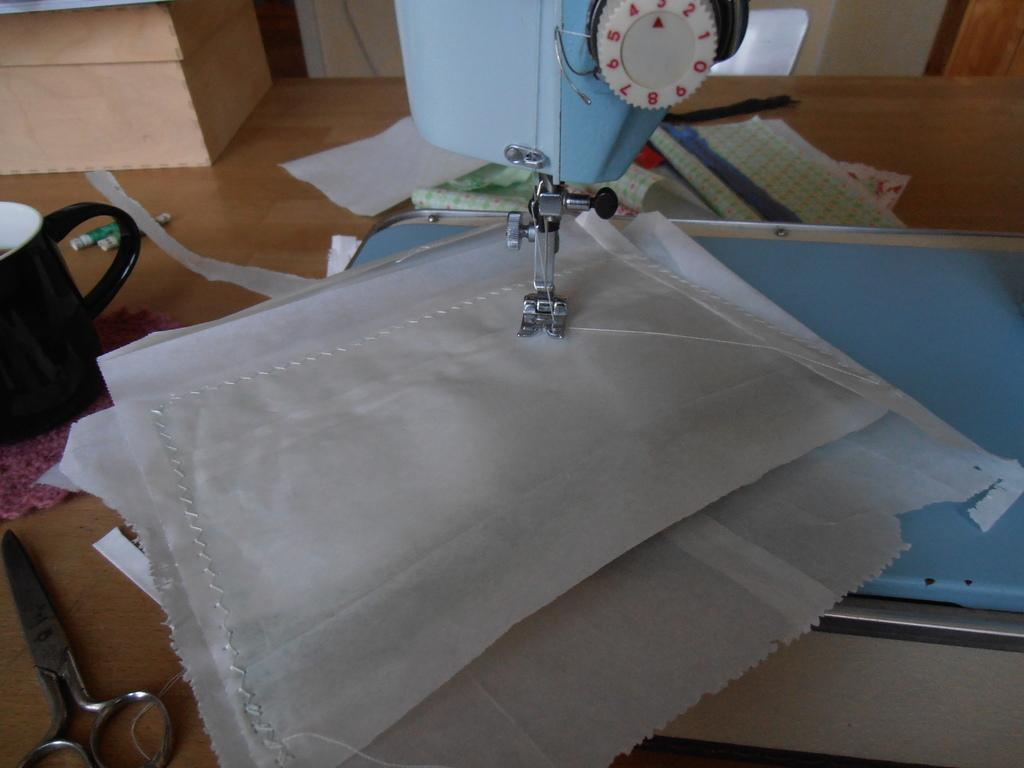What is the main object in the picture? There is a sewing machine in the picture. What else can be seen on the table in the picture? There are papers, scissors, a cup, thread rolls, and other objects on the table. What might be used for cutting in the picture? Scissors can be used for cutting in the picture. What might be used for holding liquids in the picture? There is a cup on the table that might be used for holding liquids. What type of debt is being discussed in the picture? There is no mention of debt in the picture; it features a sewing machine and objects on a table. How many trucks are visible in the picture? There are no trucks visible in the picture; it features a sewing machine and objects on a table. 